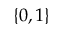Convert formula to latex. <formula><loc_0><loc_0><loc_500><loc_500>\{ 0 , 1 \}</formula> 